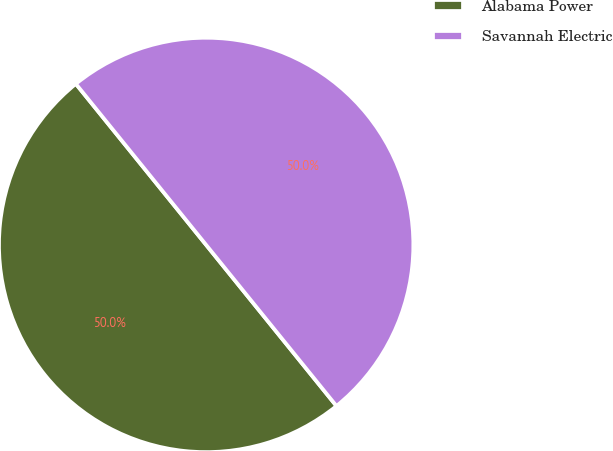Convert chart to OTSL. <chart><loc_0><loc_0><loc_500><loc_500><pie_chart><fcel>Alabama Power<fcel>Savannah Electric<nl><fcel>50.0%<fcel>50.0%<nl></chart> 